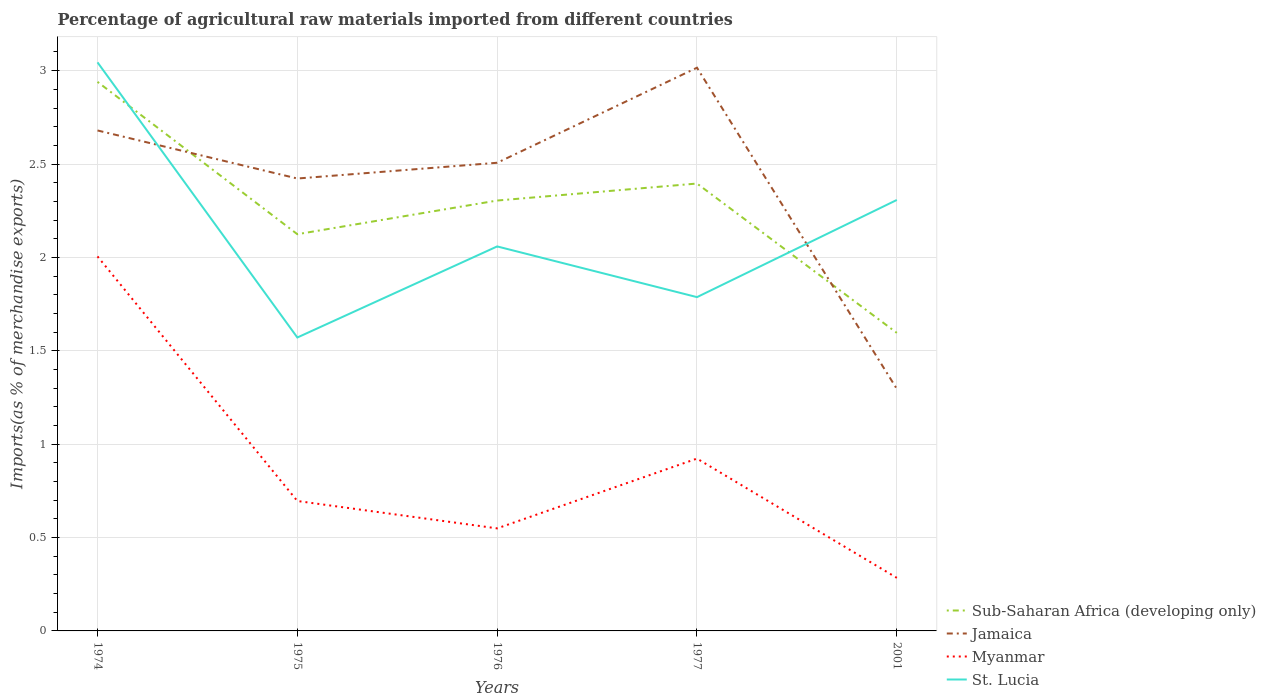Is the number of lines equal to the number of legend labels?
Offer a very short reply. Yes. Across all years, what is the maximum percentage of imports to different countries in Myanmar?
Offer a very short reply. 0.28. What is the total percentage of imports to different countries in Sub-Saharan Africa (developing only) in the graph?
Offer a very short reply. 0.71. What is the difference between the highest and the second highest percentage of imports to different countries in Sub-Saharan Africa (developing only)?
Your answer should be compact. 1.34. What is the difference between the highest and the lowest percentage of imports to different countries in Myanmar?
Keep it short and to the point. 2. How many lines are there?
Your answer should be very brief. 4. How many years are there in the graph?
Provide a succinct answer. 5. Does the graph contain grids?
Provide a succinct answer. Yes. Where does the legend appear in the graph?
Ensure brevity in your answer.  Bottom right. How many legend labels are there?
Keep it short and to the point. 4. How are the legend labels stacked?
Provide a short and direct response. Vertical. What is the title of the graph?
Provide a succinct answer. Percentage of agricultural raw materials imported from different countries. What is the label or title of the X-axis?
Your answer should be compact. Years. What is the label or title of the Y-axis?
Make the answer very short. Imports(as % of merchandise exports). What is the Imports(as % of merchandise exports) of Sub-Saharan Africa (developing only) in 1974?
Give a very brief answer. 2.94. What is the Imports(as % of merchandise exports) of Jamaica in 1974?
Make the answer very short. 2.68. What is the Imports(as % of merchandise exports) of Myanmar in 1974?
Ensure brevity in your answer.  2.01. What is the Imports(as % of merchandise exports) in St. Lucia in 1974?
Give a very brief answer. 3.04. What is the Imports(as % of merchandise exports) in Sub-Saharan Africa (developing only) in 1975?
Keep it short and to the point. 2.12. What is the Imports(as % of merchandise exports) of Jamaica in 1975?
Provide a short and direct response. 2.42. What is the Imports(as % of merchandise exports) of Myanmar in 1975?
Ensure brevity in your answer.  0.7. What is the Imports(as % of merchandise exports) in St. Lucia in 1975?
Your answer should be compact. 1.57. What is the Imports(as % of merchandise exports) in Sub-Saharan Africa (developing only) in 1976?
Your answer should be compact. 2.3. What is the Imports(as % of merchandise exports) in Jamaica in 1976?
Your answer should be compact. 2.51. What is the Imports(as % of merchandise exports) in Myanmar in 1976?
Ensure brevity in your answer.  0.55. What is the Imports(as % of merchandise exports) in St. Lucia in 1976?
Keep it short and to the point. 2.06. What is the Imports(as % of merchandise exports) in Sub-Saharan Africa (developing only) in 1977?
Offer a terse response. 2.4. What is the Imports(as % of merchandise exports) in Jamaica in 1977?
Provide a short and direct response. 3.02. What is the Imports(as % of merchandise exports) in Myanmar in 1977?
Your answer should be compact. 0.92. What is the Imports(as % of merchandise exports) in St. Lucia in 1977?
Give a very brief answer. 1.79. What is the Imports(as % of merchandise exports) of Sub-Saharan Africa (developing only) in 2001?
Your answer should be very brief. 1.6. What is the Imports(as % of merchandise exports) in Jamaica in 2001?
Make the answer very short. 1.3. What is the Imports(as % of merchandise exports) in Myanmar in 2001?
Ensure brevity in your answer.  0.28. What is the Imports(as % of merchandise exports) of St. Lucia in 2001?
Offer a very short reply. 2.31. Across all years, what is the maximum Imports(as % of merchandise exports) in Sub-Saharan Africa (developing only)?
Your answer should be very brief. 2.94. Across all years, what is the maximum Imports(as % of merchandise exports) in Jamaica?
Your response must be concise. 3.02. Across all years, what is the maximum Imports(as % of merchandise exports) in Myanmar?
Provide a succinct answer. 2.01. Across all years, what is the maximum Imports(as % of merchandise exports) of St. Lucia?
Offer a terse response. 3.04. Across all years, what is the minimum Imports(as % of merchandise exports) in Sub-Saharan Africa (developing only)?
Your answer should be compact. 1.6. Across all years, what is the minimum Imports(as % of merchandise exports) of Jamaica?
Offer a very short reply. 1.3. Across all years, what is the minimum Imports(as % of merchandise exports) in Myanmar?
Give a very brief answer. 0.28. Across all years, what is the minimum Imports(as % of merchandise exports) in St. Lucia?
Make the answer very short. 1.57. What is the total Imports(as % of merchandise exports) of Sub-Saharan Africa (developing only) in the graph?
Your answer should be compact. 11.36. What is the total Imports(as % of merchandise exports) of Jamaica in the graph?
Provide a succinct answer. 11.92. What is the total Imports(as % of merchandise exports) in Myanmar in the graph?
Your answer should be compact. 4.46. What is the total Imports(as % of merchandise exports) in St. Lucia in the graph?
Provide a short and direct response. 10.77. What is the difference between the Imports(as % of merchandise exports) in Sub-Saharan Africa (developing only) in 1974 and that in 1975?
Ensure brevity in your answer.  0.82. What is the difference between the Imports(as % of merchandise exports) of Jamaica in 1974 and that in 1975?
Offer a very short reply. 0.26. What is the difference between the Imports(as % of merchandise exports) of Myanmar in 1974 and that in 1975?
Your answer should be compact. 1.31. What is the difference between the Imports(as % of merchandise exports) in St. Lucia in 1974 and that in 1975?
Your response must be concise. 1.47. What is the difference between the Imports(as % of merchandise exports) in Sub-Saharan Africa (developing only) in 1974 and that in 1976?
Provide a succinct answer. 0.64. What is the difference between the Imports(as % of merchandise exports) in Jamaica in 1974 and that in 1976?
Offer a very short reply. 0.17. What is the difference between the Imports(as % of merchandise exports) in Myanmar in 1974 and that in 1976?
Provide a short and direct response. 1.46. What is the difference between the Imports(as % of merchandise exports) of St. Lucia in 1974 and that in 1976?
Your answer should be very brief. 0.99. What is the difference between the Imports(as % of merchandise exports) of Sub-Saharan Africa (developing only) in 1974 and that in 1977?
Provide a short and direct response. 0.54. What is the difference between the Imports(as % of merchandise exports) in Jamaica in 1974 and that in 1977?
Make the answer very short. -0.34. What is the difference between the Imports(as % of merchandise exports) in Myanmar in 1974 and that in 1977?
Your answer should be compact. 1.08. What is the difference between the Imports(as % of merchandise exports) of St. Lucia in 1974 and that in 1977?
Provide a short and direct response. 1.26. What is the difference between the Imports(as % of merchandise exports) of Sub-Saharan Africa (developing only) in 1974 and that in 2001?
Your answer should be very brief. 1.34. What is the difference between the Imports(as % of merchandise exports) of Jamaica in 1974 and that in 2001?
Offer a terse response. 1.38. What is the difference between the Imports(as % of merchandise exports) in Myanmar in 1974 and that in 2001?
Give a very brief answer. 1.72. What is the difference between the Imports(as % of merchandise exports) in St. Lucia in 1974 and that in 2001?
Offer a very short reply. 0.74. What is the difference between the Imports(as % of merchandise exports) of Sub-Saharan Africa (developing only) in 1975 and that in 1976?
Make the answer very short. -0.18. What is the difference between the Imports(as % of merchandise exports) in Jamaica in 1975 and that in 1976?
Your response must be concise. -0.08. What is the difference between the Imports(as % of merchandise exports) of Myanmar in 1975 and that in 1976?
Make the answer very short. 0.15. What is the difference between the Imports(as % of merchandise exports) in St. Lucia in 1975 and that in 1976?
Your response must be concise. -0.49. What is the difference between the Imports(as % of merchandise exports) of Sub-Saharan Africa (developing only) in 1975 and that in 1977?
Offer a very short reply. -0.27. What is the difference between the Imports(as % of merchandise exports) in Jamaica in 1975 and that in 1977?
Give a very brief answer. -0.59. What is the difference between the Imports(as % of merchandise exports) of Myanmar in 1975 and that in 1977?
Provide a succinct answer. -0.23. What is the difference between the Imports(as % of merchandise exports) of St. Lucia in 1975 and that in 1977?
Provide a succinct answer. -0.22. What is the difference between the Imports(as % of merchandise exports) in Sub-Saharan Africa (developing only) in 1975 and that in 2001?
Provide a succinct answer. 0.53. What is the difference between the Imports(as % of merchandise exports) of Jamaica in 1975 and that in 2001?
Keep it short and to the point. 1.13. What is the difference between the Imports(as % of merchandise exports) of Myanmar in 1975 and that in 2001?
Keep it short and to the point. 0.41. What is the difference between the Imports(as % of merchandise exports) in St. Lucia in 1975 and that in 2001?
Make the answer very short. -0.74. What is the difference between the Imports(as % of merchandise exports) in Sub-Saharan Africa (developing only) in 1976 and that in 1977?
Your response must be concise. -0.09. What is the difference between the Imports(as % of merchandise exports) of Jamaica in 1976 and that in 1977?
Give a very brief answer. -0.51. What is the difference between the Imports(as % of merchandise exports) of Myanmar in 1976 and that in 1977?
Ensure brevity in your answer.  -0.37. What is the difference between the Imports(as % of merchandise exports) of St. Lucia in 1976 and that in 1977?
Your response must be concise. 0.27. What is the difference between the Imports(as % of merchandise exports) in Sub-Saharan Africa (developing only) in 1976 and that in 2001?
Your answer should be compact. 0.71. What is the difference between the Imports(as % of merchandise exports) of Jamaica in 1976 and that in 2001?
Your response must be concise. 1.21. What is the difference between the Imports(as % of merchandise exports) of Myanmar in 1976 and that in 2001?
Ensure brevity in your answer.  0.26. What is the difference between the Imports(as % of merchandise exports) in St. Lucia in 1976 and that in 2001?
Provide a short and direct response. -0.25. What is the difference between the Imports(as % of merchandise exports) of Sub-Saharan Africa (developing only) in 1977 and that in 2001?
Offer a terse response. 0.8. What is the difference between the Imports(as % of merchandise exports) of Jamaica in 1977 and that in 2001?
Provide a short and direct response. 1.72. What is the difference between the Imports(as % of merchandise exports) in Myanmar in 1977 and that in 2001?
Give a very brief answer. 0.64. What is the difference between the Imports(as % of merchandise exports) of St. Lucia in 1977 and that in 2001?
Offer a terse response. -0.52. What is the difference between the Imports(as % of merchandise exports) in Sub-Saharan Africa (developing only) in 1974 and the Imports(as % of merchandise exports) in Jamaica in 1975?
Offer a terse response. 0.52. What is the difference between the Imports(as % of merchandise exports) of Sub-Saharan Africa (developing only) in 1974 and the Imports(as % of merchandise exports) of Myanmar in 1975?
Give a very brief answer. 2.24. What is the difference between the Imports(as % of merchandise exports) of Sub-Saharan Africa (developing only) in 1974 and the Imports(as % of merchandise exports) of St. Lucia in 1975?
Make the answer very short. 1.37. What is the difference between the Imports(as % of merchandise exports) in Jamaica in 1974 and the Imports(as % of merchandise exports) in Myanmar in 1975?
Ensure brevity in your answer.  1.98. What is the difference between the Imports(as % of merchandise exports) in Jamaica in 1974 and the Imports(as % of merchandise exports) in St. Lucia in 1975?
Your answer should be very brief. 1.11. What is the difference between the Imports(as % of merchandise exports) of Myanmar in 1974 and the Imports(as % of merchandise exports) of St. Lucia in 1975?
Keep it short and to the point. 0.43. What is the difference between the Imports(as % of merchandise exports) in Sub-Saharan Africa (developing only) in 1974 and the Imports(as % of merchandise exports) in Jamaica in 1976?
Keep it short and to the point. 0.43. What is the difference between the Imports(as % of merchandise exports) in Sub-Saharan Africa (developing only) in 1974 and the Imports(as % of merchandise exports) in Myanmar in 1976?
Give a very brief answer. 2.39. What is the difference between the Imports(as % of merchandise exports) in Sub-Saharan Africa (developing only) in 1974 and the Imports(as % of merchandise exports) in St. Lucia in 1976?
Provide a short and direct response. 0.88. What is the difference between the Imports(as % of merchandise exports) in Jamaica in 1974 and the Imports(as % of merchandise exports) in Myanmar in 1976?
Your answer should be compact. 2.13. What is the difference between the Imports(as % of merchandise exports) of Jamaica in 1974 and the Imports(as % of merchandise exports) of St. Lucia in 1976?
Make the answer very short. 0.62. What is the difference between the Imports(as % of merchandise exports) of Myanmar in 1974 and the Imports(as % of merchandise exports) of St. Lucia in 1976?
Offer a very short reply. -0.05. What is the difference between the Imports(as % of merchandise exports) in Sub-Saharan Africa (developing only) in 1974 and the Imports(as % of merchandise exports) in Jamaica in 1977?
Your response must be concise. -0.08. What is the difference between the Imports(as % of merchandise exports) in Sub-Saharan Africa (developing only) in 1974 and the Imports(as % of merchandise exports) in Myanmar in 1977?
Your response must be concise. 2.02. What is the difference between the Imports(as % of merchandise exports) of Sub-Saharan Africa (developing only) in 1974 and the Imports(as % of merchandise exports) of St. Lucia in 1977?
Make the answer very short. 1.15. What is the difference between the Imports(as % of merchandise exports) in Jamaica in 1974 and the Imports(as % of merchandise exports) in Myanmar in 1977?
Give a very brief answer. 1.76. What is the difference between the Imports(as % of merchandise exports) of Jamaica in 1974 and the Imports(as % of merchandise exports) of St. Lucia in 1977?
Your response must be concise. 0.89. What is the difference between the Imports(as % of merchandise exports) in Myanmar in 1974 and the Imports(as % of merchandise exports) in St. Lucia in 1977?
Provide a short and direct response. 0.22. What is the difference between the Imports(as % of merchandise exports) of Sub-Saharan Africa (developing only) in 1974 and the Imports(as % of merchandise exports) of Jamaica in 2001?
Give a very brief answer. 1.64. What is the difference between the Imports(as % of merchandise exports) in Sub-Saharan Africa (developing only) in 1974 and the Imports(as % of merchandise exports) in Myanmar in 2001?
Your response must be concise. 2.66. What is the difference between the Imports(as % of merchandise exports) of Sub-Saharan Africa (developing only) in 1974 and the Imports(as % of merchandise exports) of St. Lucia in 2001?
Provide a short and direct response. 0.63. What is the difference between the Imports(as % of merchandise exports) of Jamaica in 1974 and the Imports(as % of merchandise exports) of Myanmar in 2001?
Offer a very short reply. 2.4. What is the difference between the Imports(as % of merchandise exports) in Jamaica in 1974 and the Imports(as % of merchandise exports) in St. Lucia in 2001?
Your response must be concise. 0.37. What is the difference between the Imports(as % of merchandise exports) in Myanmar in 1974 and the Imports(as % of merchandise exports) in St. Lucia in 2001?
Your answer should be compact. -0.3. What is the difference between the Imports(as % of merchandise exports) of Sub-Saharan Africa (developing only) in 1975 and the Imports(as % of merchandise exports) of Jamaica in 1976?
Your response must be concise. -0.38. What is the difference between the Imports(as % of merchandise exports) of Sub-Saharan Africa (developing only) in 1975 and the Imports(as % of merchandise exports) of Myanmar in 1976?
Your answer should be compact. 1.58. What is the difference between the Imports(as % of merchandise exports) of Sub-Saharan Africa (developing only) in 1975 and the Imports(as % of merchandise exports) of St. Lucia in 1976?
Provide a succinct answer. 0.07. What is the difference between the Imports(as % of merchandise exports) of Jamaica in 1975 and the Imports(as % of merchandise exports) of Myanmar in 1976?
Give a very brief answer. 1.87. What is the difference between the Imports(as % of merchandise exports) of Jamaica in 1975 and the Imports(as % of merchandise exports) of St. Lucia in 1976?
Make the answer very short. 0.36. What is the difference between the Imports(as % of merchandise exports) of Myanmar in 1975 and the Imports(as % of merchandise exports) of St. Lucia in 1976?
Offer a terse response. -1.36. What is the difference between the Imports(as % of merchandise exports) in Sub-Saharan Africa (developing only) in 1975 and the Imports(as % of merchandise exports) in Jamaica in 1977?
Your response must be concise. -0.89. What is the difference between the Imports(as % of merchandise exports) in Sub-Saharan Africa (developing only) in 1975 and the Imports(as % of merchandise exports) in Myanmar in 1977?
Offer a very short reply. 1.2. What is the difference between the Imports(as % of merchandise exports) of Sub-Saharan Africa (developing only) in 1975 and the Imports(as % of merchandise exports) of St. Lucia in 1977?
Offer a very short reply. 0.34. What is the difference between the Imports(as % of merchandise exports) in Jamaica in 1975 and the Imports(as % of merchandise exports) in Myanmar in 1977?
Provide a succinct answer. 1.5. What is the difference between the Imports(as % of merchandise exports) in Jamaica in 1975 and the Imports(as % of merchandise exports) in St. Lucia in 1977?
Ensure brevity in your answer.  0.64. What is the difference between the Imports(as % of merchandise exports) of Myanmar in 1975 and the Imports(as % of merchandise exports) of St. Lucia in 1977?
Make the answer very short. -1.09. What is the difference between the Imports(as % of merchandise exports) of Sub-Saharan Africa (developing only) in 1975 and the Imports(as % of merchandise exports) of Jamaica in 2001?
Your answer should be very brief. 0.83. What is the difference between the Imports(as % of merchandise exports) of Sub-Saharan Africa (developing only) in 1975 and the Imports(as % of merchandise exports) of Myanmar in 2001?
Provide a succinct answer. 1.84. What is the difference between the Imports(as % of merchandise exports) of Sub-Saharan Africa (developing only) in 1975 and the Imports(as % of merchandise exports) of St. Lucia in 2001?
Keep it short and to the point. -0.18. What is the difference between the Imports(as % of merchandise exports) of Jamaica in 1975 and the Imports(as % of merchandise exports) of Myanmar in 2001?
Provide a succinct answer. 2.14. What is the difference between the Imports(as % of merchandise exports) of Jamaica in 1975 and the Imports(as % of merchandise exports) of St. Lucia in 2001?
Your answer should be compact. 0.11. What is the difference between the Imports(as % of merchandise exports) of Myanmar in 1975 and the Imports(as % of merchandise exports) of St. Lucia in 2001?
Your answer should be very brief. -1.61. What is the difference between the Imports(as % of merchandise exports) in Sub-Saharan Africa (developing only) in 1976 and the Imports(as % of merchandise exports) in Jamaica in 1977?
Your answer should be compact. -0.71. What is the difference between the Imports(as % of merchandise exports) of Sub-Saharan Africa (developing only) in 1976 and the Imports(as % of merchandise exports) of Myanmar in 1977?
Offer a very short reply. 1.38. What is the difference between the Imports(as % of merchandise exports) in Sub-Saharan Africa (developing only) in 1976 and the Imports(as % of merchandise exports) in St. Lucia in 1977?
Your answer should be very brief. 0.52. What is the difference between the Imports(as % of merchandise exports) of Jamaica in 1976 and the Imports(as % of merchandise exports) of Myanmar in 1977?
Provide a short and direct response. 1.58. What is the difference between the Imports(as % of merchandise exports) in Jamaica in 1976 and the Imports(as % of merchandise exports) in St. Lucia in 1977?
Your answer should be very brief. 0.72. What is the difference between the Imports(as % of merchandise exports) of Myanmar in 1976 and the Imports(as % of merchandise exports) of St. Lucia in 1977?
Offer a terse response. -1.24. What is the difference between the Imports(as % of merchandise exports) in Sub-Saharan Africa (developing only) in 1976 and the Imports(as % of merchandise exports) in Jamaica in 2001?
Your answer should be compact. 1.01. What is the difference between the Imports(as % of merchandise exports) in Sub-Saharan Africa (developing only) in 1976 and the Imports(as % of merchandise exports) in Myanmar in 2001?
Give a very brief answer. 2.02. What is the difference between the Imports(as % of merchandise exports) of Sub-Saharan Africa (developing only) in 1976 and the Imports(as % of merchandise exports) of St. Lucia in 2001?
Your answer should be compact. -0. What is the difference between the Imports(as % of merchandise exports) in Jamaica in 1976 and the Imports(as % of merchandise exports) in Myanmar in 2001?
Ensure brevity in your answer.  2.22. What is the difference between the Imports(as % of merchandise exports) in Jamaica in 1976 and the Imports(as % of merchandise exports) in St. Lucia in 2001?
Offer a terse response. 0.2. What is the difference between the Imports(as % of merchandise exports) of Myanmar in 1976 and the Imports(as % of merchandise exports) of St. Lucia in 2001?
Offer a terse response. -1.76. What is the difference between the Imports(as % of merchandise exports) of Sub-Saharan Africa (developing only) in 1977 and the Imports(as % of merchandise exports) of Jamaica in 2001?
Your answer should be very brief. 1.1. What is the difference between the Imports(as % of merchandise exports) of Sub-Saharan Africa (developing only) in 1977 and the Imports(as % of merchandise exports) of Myanmar in 2001?
Offer a very short reply. 2.11. What is the difference between the Imports(as % of merchandise exports) in Sub-Saharan Africa (developing only) in 1977 and the Imports(as % of merchandise exports) in St. Lucia in 2001?
Your answer should be very brief. 0.09. What is the difference between the Imports(as % of merchandise exports) in Jamaica in 1977 and the Imports(as % of merchandise exports) in Myanmar in 2001?
Your answer should be compact. 2.73. What is the difference between the Imports(as % of merchandise exports) of Jamaica in 1977 and the Imports(as % of merchandise exports) of St. Lucia in 2001?
Ensure brevity in your answer.  0.71. What is the difference between the Imports(as % of merchandise exports) of Myanmar in 1977 and the Imports(as % of merchandise exports) of St. Lucia in 2001?
Your answer should be compact. -1.38. What is the average Imports(as % of merchandise exports) in Sub-Saharan Africa (developing only) per year?
Offer a very short reply. 2.27. What is the average Imports(as % of merchandise exports) of Jamaica per year?
Give a very brief answer. 2.38. What is the average Imports(as % of merchandise exports) of Myanmar per year?
Make the answer very short. 0.89. What is the average Imports(as % of merchandise exports) of St. Lucia per year?
Ensure brevity in your answer.  2.15. In the year 1974, what is the difference between the Imports(as % of merchandise exports) of Sub-Saharan Africa (developing only) and Imports(as % of merchandise exports) of Jamaica?
Your response must be concise. 0.26. In the year 1974, what is the difference between the Imports(as % of merchandise exports) of Sub-Saharan Africa (developing only) and Imports(as % of merchandise exports) of Myanmar?
Offer a terse response. 0.93. In the year 1974, what is the difference between the Imports(as % of merchandise exports) in Sub-Saharan Africa (developing only) and Imports(as % of merchandise exports) in St. Lucia?
Keep it short and to the point. -0.1. In the year 1974, what is the difference between the Imports(as % of merchandise exports) in Jamaica and Imports(as % of merchandise exports) in Myanmar?
Give a very brief answer. 0.67. In the year 1974, what is the difference between the Imports(as % of merchandise exports) in Jamaica and Imports(as % of merchandise exports) in St. Lucia?
Keep it short and to the point. -0.36. In the year 1974, what is the difference between the Imports(as % of merchandise exports) of Myanmar and Imports(as % of merchandise exports) of St. Lucia?
Ensure brevity in your answer.  -1.04. In the year 1975, what is the difference between the Imports(as % of merchandise exports) in Sub-Saharan Africa (developing only) and Imports(as % of merchandise exports) in Jamaica?
Provide a short and direct response. -0.3. In the year 1975, what is the difference between the Imports(as % of merchandise exports) of Sub-Saharan Africa (developing only) and Imports(as % of merchandise exports) of Myanmar?
Your answer should be compact. 1.43. In the year 1975, what is the difference between the Imports(as % of merchandise exports) of Sub-Saharan Africa (developing only) and Imports(as % of merchandise exports) of St. Lucia?
Your answer should be compact. 0.55. In the year 1975, what is the difference between the Imports(as % of merchandise exports) of Jamaica and Imports(as % of merchandise exports) of Myanmar?
Give a very brief answer. 1.73. In the year 1975, what is the difference between the Imports(as % of merchandise exports) in Jamaica and Imports(as % of merchandise exports) in St. Lucia?
Give a very brief answer. 0.85. In the year 1975, what is the difference between the Imports(as % of merchandise exports) of Myanmar and Imports(as % of merchandise exports) of St. Lucia?
Provide a succinct answer. -0.88. In the year 1976, what is the difference between the Imports(as % of merchandise exports) in Sub-Saharan Africa (developing only) and Imports(as % of merchandise exports) in Jamaica?
Give a very brief answer. -0.2. In the year 1976, what is the difference between the Imports(as % of merchandise exports) in Sub-Saharan Africa (developing only) and Imports(as % of merchandise exports) in Myanmar?
Offer a terse response. 1.76. In the year 1976, what is the difference between the Imports(as % of merchandise exports) in Sub-Saharan Africa (developing only) and Imports(as % of merchandise exports) in St. Lucia?
Your answer should be very brief. 0.25. In the year 1976, what is the difference between the Imports(as % of merchandise exports) in Jamaica and Imports(as % of merchandise exports) in Myanmar?
Your answer should be very brief. 1.96. In the year 1976, what is the difference between the Imports(as % of merchandise exports) in Jamaica and Imports(as % of merchandise exports) in St. Lucia?
Your response must be concise. 0.45. In the year 1976, what is the difference between the Imports(as % of merchandise exports) of Myanmar and Imports(as % of merchandise exports) of St. Lucia?
Give a very brief answer. -1.51. In the year 1977, what is the difference between the Imports(as % of merchandise exports) of Sub-Saharan Africa (developing only) and Imports(as % of merchandise exports) of Jamaica?
Your answer should be compact. -0.62. In the year 1977, what is the difference between the Imports(as % of merchandise exports) of Sub-Saharan Africa (developing only) and Imports(as % of merchandise exports) of Myanmar?
Your response must be concise. 1.47. In the year 1977, what is the difference between the Imports(as % of merchandise exports) in Sub-Saharan Africa (developing only) and Imports(as % of merchandise exports) in St. Lucia?
Ensure brevity in your answer.  0.61. In the year 1977, what is the difference between the Imports(as % of merchandise exports) of Jamaica and Imports(as % of merchandise exports) of Myanmar?
Offer a terse response. 2.09. In the year 1977, what is the difference between the Imports(as % of merchandise exports) in Jamaica and Imports(as % of merchandise exports) in St. Lucia?
Offer a very short reply. 1.23. In the year 1977, what is the difference between the Imports(as % of merchandise exports) of Myanmar and Imports(as % of merchandise exports) of St. Lucia?
Ensure brevity in your answer.  -0.86. In the year 2001, what is the difference between the Imports(as % of merchandise exports) of Sub-Saharan Africa (developing only) and Imports(as % of merchandise exports) of Jamaica?
Offer a very short reply. 0.3. In the year 2001, what is the difference between the Imports(as % of merchandise exports) of Sub-Saharan Africa (developing only) and Imports(as % of merchandise exports) of Myanmar?
Your answer should be compact. 1.31. In the year 2001, what is the difference between the Imports(as % of merchandise exports) of Sub-Saharan Africa (developing only) and Imports(as % of merchandise exports) of St. Lucia?
Offer a very short reply. -0.71. In the year 2001, what is the difference between the Imports(as % of merchandise exports) of Jamaica and Imports(as % of merchandise exports) of Myanmar?
Provide a short and direct response. 1.01. In the year 2001, what is the difference between the Imports(as % of merchandise exports) in Jamaica and Imports(as % of merchandise exports) in St. Lucia?
Offer a very short reply. -1.01. In the year 2001, what is the difference between the Imports(as % of merchandise exports) in Myanmar and Imports(as % of merchandise exports) in St. Lucia?
Your response must be concise. -2.02. What is the ratio of the Imports(as % of merchandise exports) of Sub-Saharan Africa (developing only) in 1974 to that in 1975?
Your response must be concise. 1.38. What is the ratio of the Imports(as % of merchandise exports) in Jamaica in 1974 to that in 1975?
Give a very brief answer. 1.11. What is the ratio of the Imports(as % of merchandise exports) of Myanmar in 1974 to that in 1975?
Give a very brief answer. 2.88. What is the ratio of the Imports(as % of merchandise exports) of St. Lucia in 1974 to that in 1975?
Ensure brevity in your answer.  1.94. What is the ratio of the Imports(as % of merchandise exports) of Sub-Saharan Africa (developing only) in 1974 to that in 1976?
Give a very brief answer. 1.28. What is the ratio of the Imports(as % of merchandise exports) of Jamaica in 1974 to that in 1976?
Provide a succinct answer. 1.07. What is the ratio of the Imports(as % of merchandise exports) of Myanmar in 1974 to that in 1976?
Your response must be concise. 3.65. What is the ratio of the Imports(as % of merchandise exports) in St. Lucia in 1974 to that in 1976?
Provide a succinct answer. 1.48. What is the ratio of the Imports(as % of merchandise exports) of Sub-Saharan Africa (developing only) in 1974 to that in 1977?
Provide a short and direct response. 1.23. What is the ratio of the Imports(as % of merchandise exports) in Jamaica in 1974 to that in 1977?
Make the answer very short. 0.89. What is the ratio of the Imports(as % of merchandise exports) of Myanmar in 1974 to that in 1977?
Make the answer very short. 2.17. What is the ratio of the Imports(as % of merchandise exports) in St. Lucia in 1974 to that in 1977?
Offer a very short reply. 1.7. What is the ratio of the Imports(as % of merchandise exports) of Sub-Saharan Africa (developing only) in 1974 to that in 2001?
Provide a short and direct response. 1.84. What is the ratio of the Imports(as % of merchandise exports) in Jamaica in 1974 to that in 2001?
Offer a very short reply. 2.07. What is the ratio of the Imports(as % of merchandise exports) of Myanmar in 1974 to that in 2001?
Your response must be concise. 7.06. What is the ratio of the Imports(as % of merchandise exports) in St. Lucia in 1974 to that in 2001?
Keep it short and to the point. 1.32. What is the ratio of the Imports(as % of merchandise exports) in Sub-Saharan Africa (developing only) in 1975 to that in 1976?
Make the answer very short. 0.92. What is the ratio of the Imports(as % of merchandise exports) in Jamaica in 1975 to that in 1976?
Provide a short and direct response. 0.97. What is the ratio of the Imports(as % of merchandise exports) in Myanmar in 1975 to that in 1976?
Keep it short and to the point. 1.27. What is the ratio of the Imports(as % of merchandise exports) in St. Lucia in 1975 to that in 1976?
Provide a short and direct response. 0.76. What is the ratio of the Imports(as % of merchandise exports) of Sub-Saharan Africa (developing only) in 1975 to that in 1977?
Your answer should be compact. 0.89. What is the ratio of the Imports(as % of merchandise exports) in Jamaica in 1975 to that in 1977?
Your answer should be very brief. 0.8. What is the ratio of the Imports(as % of merchandise exports) in Myanmar in 1975 to that in 1977?
Give a very brief answer. 0.75. What is the ratio of the Imports(as % of merchandise exports) of St. Lucia in 1975 to that in 1977?
Provide a succinct answer. 0.88. What is the ratio of the Imports(as % of merchandise exports) of Sub-Saharan Africa (developing only) in 1975 to that in 2001?
Offer a terse response. 1.33. What is the ratio of the Imports(as % of merchandise exports) in Jamaica in 1975 to that in 2001?
Your answer should be very brief. 1.87. What is the ratio of the Imports(as % of merchandise exports) in Myanmar in 1975 to that in 2001?
Provide a short and direct response. 2.45. What is the ratio of the Imports(as % of merchandise exports) of St. Lucia in 1975 to that in 2001?
Provide a short and direct response. 0.68. What is the ratio of the Imports(as % of merchandise exports) in Sub-Saharan Africa (developing only) in 1976 to that in 1977?
Your response must be concise. 0.96. What is the ratio of the Imports(as % of merchandise exports) in Jamaica in 1976 to that in 1977?
Ensure brevity in your answer.  0.83. What is the ratio of the Imports(as % of merchandise exports) in Myanmar in 1976 to that in 1977?
Your answer should be very brief. 0.59. What is the ratio of the Imports(as % of merchandise exports) in St. Lucia in 1976 to that in 1977?
Your response must be concise. 1.15. What is the ratio of the Imports(as % of merchandise exports) of Sub-Saharan Africa (developing only) in 1976 to that in 2001?
Your answer should be compact. 1.44. What is the ratio of the Imports(as % of merchandise exports) of Jamaica in 1976 to that in 2001?
Provide a succinct answer. 1.93. What is the ratio of the Imports(as % of merchandise exports) in Myanmar in 1976 to that in 2001?
Offer a terse response. 1.93. What is the ratio of the Imports(as % of merchandise exports) in St. Lucia in 1976 to that in 2001?
Offer a very short reply. 0.89. What is the ratio of the Imports(as % of merchandise exports) of Sub-Saharan Africa (developing only) in 1977 to that in 2001?
Give a very brief answer. 1.5. What is the ratio of the Imports(as % of merchandise exports) of Jamaica in 1977 to that in 2001?
Keep it short and to the point. 2.33. What is the ratio of the Imports(as % of merchandise exports) in Myanmar in 1977 to that in 2001?
Your response must be concise. 3.25. What is the ratio of the Imports(as % of merchandise exports) of St. Lucia in 1977 to that in 2001?
Offer a very short reply. 0.77. What is the difference between the highest and the second highest Imports(as % of merchandise exports) of Sub-Saharan Africa (developing only)?
Your answer should be very brief. 0.54. What is the difference between the highest and the second highest Imports(as % of merchandise exports) of Jamaica?
Keep it short and to the point. 0.34. What is the difference between the highest and the second highest Imports(as % of merchandise exports) in Myanmar?
Provide a succinct answer. 1.08. What is the difference between the highest and the second highest Imports(as % of merchandise exports) in St. Lucia?
Give a very brief answer. 0.74. What is the difference between the highest and the lowest Imports(as % of merchandise exports) in Sub-Saharan Africa (developing only)?
Offer a very short reply. 1.34. What is the difference between the highest and the lowest Imports(as % of merchandise exports) of Jamaica?
Offer a terse response. 1.72. What is the difference between the highest and the lowest Imports(as % of merchandise exports) of Myanmar?
Provide a succinct answer. 1.72. What is the difference between the highest and the lowest Imports(as % of merchandise exports) of St. Lucia?
Your answer should be very brief. 1.47. 